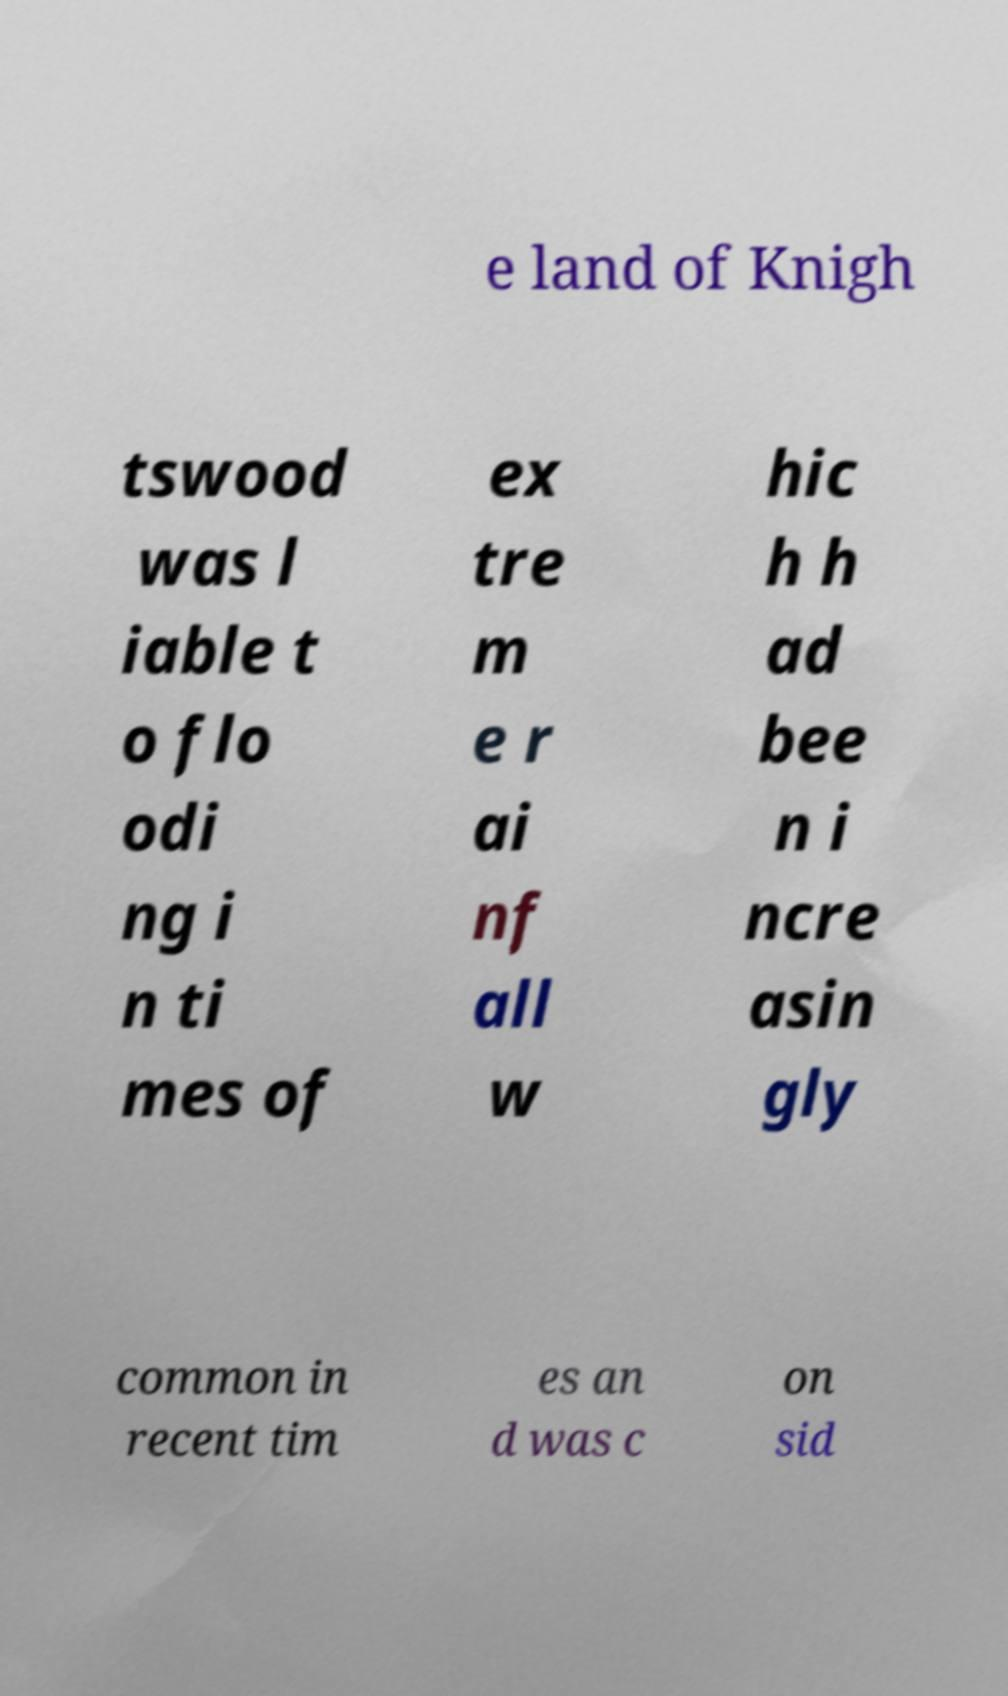Please identify and transcribe the text found in this image. e land of Knigh tswood was l iable t o flo odi ng i n ti mes of ex tre m e r ai nf all w hic h h ad bee n i ncre asin gly common in recent tim es an d was c on sid 